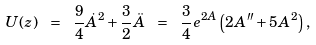<formula> <loc_0><loc_0><loc_500><loc_500>U ( z ) \ = \ \frac { 9 } { 4 } \dot { A } ^ { 2 } + \frac { 3 } { 2 } \ddot { A } \ = \ \frac { 3 } { 4 } e ^ { 2 A } \left ( 2 A ^ { \prime \prime } + 5 A ^ { 2 } \right ) ,</formula> 